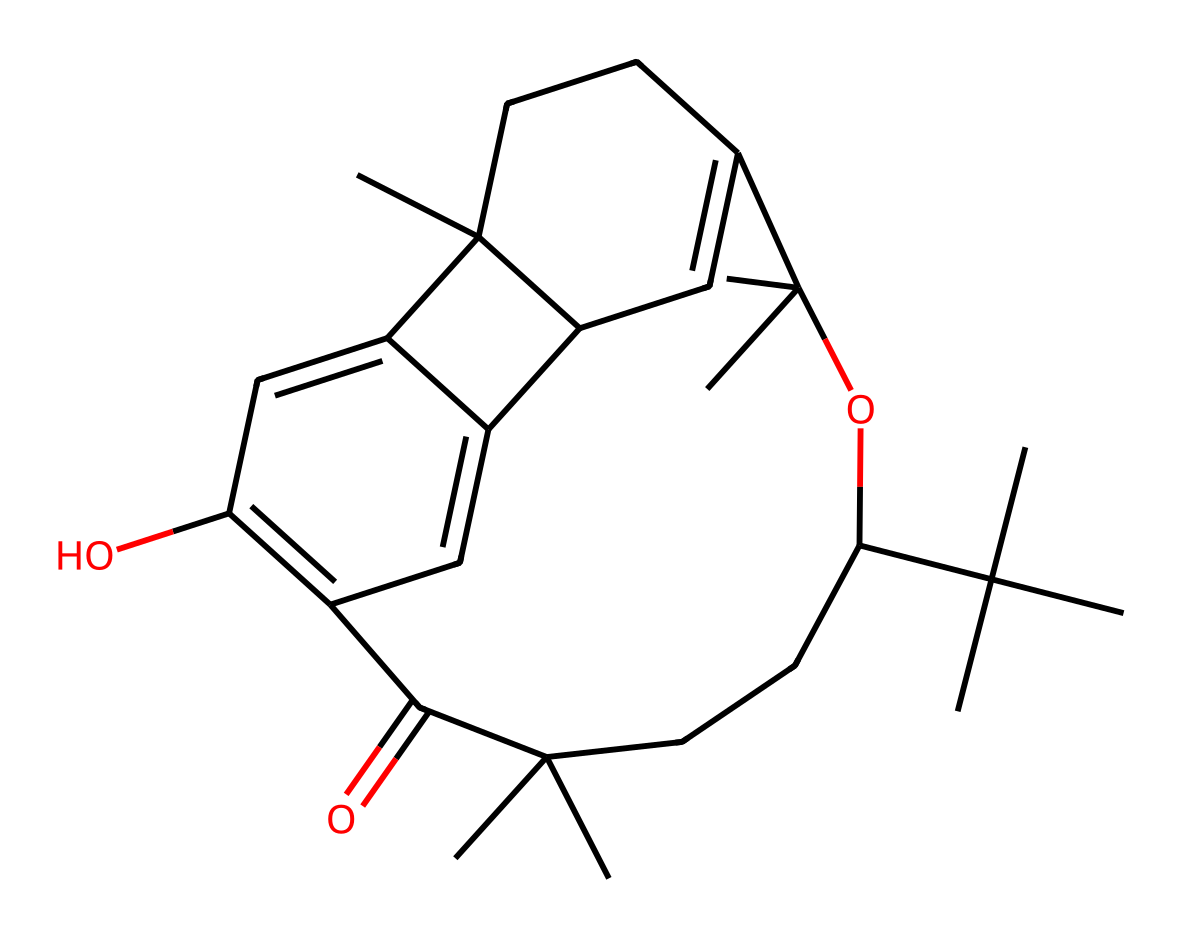What is the molecular formula of THC? To determine the molecular formula, we analyze the number of carbon (C), hydrogen (H), and oxygen (O) atoms in the provided SMILES notation. Counting the atoms leads us to the formula C21H30O2.
Answer: C21H30O2 How many rings are present in the THC structure? A careful examination of the structure reveals four distinct rings formed within the bicyclic framework typical of cannabinoids. Counting each closed loop yields a total of four rings.
Answer: 4 What functional groups are identified in THC? Analyzing the structure shows the presence of a carbonyl group (C=O) and a hydroxyl group (–OH). These groups play significant roles in the chemical's reactivity and properties.
Answer: carbonyl, hydroxyl Is THC a saturated or unsaturated compound? The presence of double bonds in its structure indicates that THC has unsaturation. The visual inspection of the molecular structure reveals multiple double (C=C) bonds present.
Answer: unsaturated What type of isomerism is exhibited by THC? THC can exhibit stereoisomerism due to the presence of multiple chiral centers in the carbon framework. This allows for different spatial arrangements of atoms in the molecule.
Answer: stereoisomerism What is the main pharmacological effect of THC? THC is well-known for its psychoactive effects, primarily acting on the cannabinoid receptors in the brain, which leads to altered perceptions, mood changes, and euphoria.
Answer: psychoactive How does the presence of oxygen in THC affect its properties? The oxygen atoms contribute to the polarity of THC, affecting its solubility in water and lipids. These properties are crucial for its bioavailability and interaction with biological systems.
Answer: polarity 